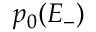Convert formula to latex. <formula><loc_0><loc_0><loc_500><loc_500>p _ { 0 } ( E _ { - } )</formula> 